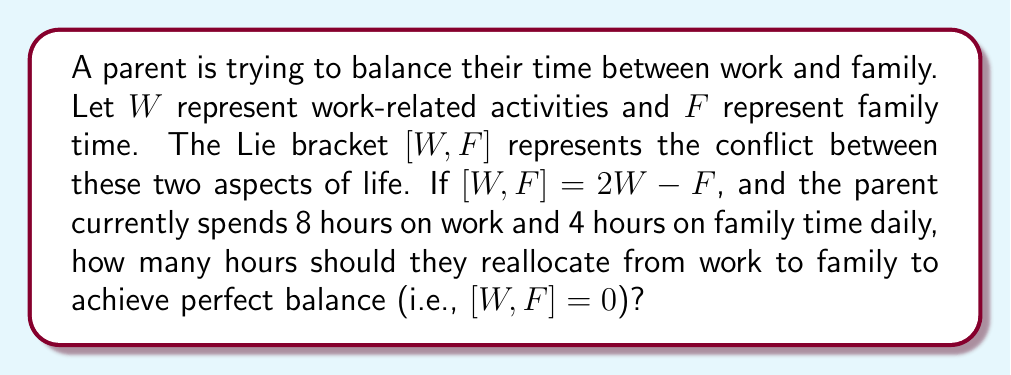Show me your answer to this math problem. Let's approach this step-by-step:

1) We're given that $[W,F] = 2W - F$

2) Currently, $W = 8$ and $F = 4$

3) To achieve balance, we need $[W,F] = 0$

4) Let $x$ be the number of hours reallocated from work to family. Then:
   New work time: $W' = 8 - x$
   New family time: $F' = 4 + x$

5) For balance: $[W',F'] = 0$
   $2W' - F' = 0$
   $2(8-x) - (4+x) = 0$

6) Simplify:
   $16 - 2x - 4 - x = 0$
   $12 - 3x = 0$

7) Solve for $x$:
   $-3x = -12$
   $x = 4$

Therefore, the parent should reallocate 4 hours from work to family time.

8) Verify:
   New work time: $W' = 8 - 4 = 4$
   New family time: $F' = 4 + 4 = 8$
   $[W',F'] = 2W' - F' = 2(4) - 8 = 0$

This confirms that perfect balance is achieved.
Answer: The parent should reallocate 4 hours from work to family time. 